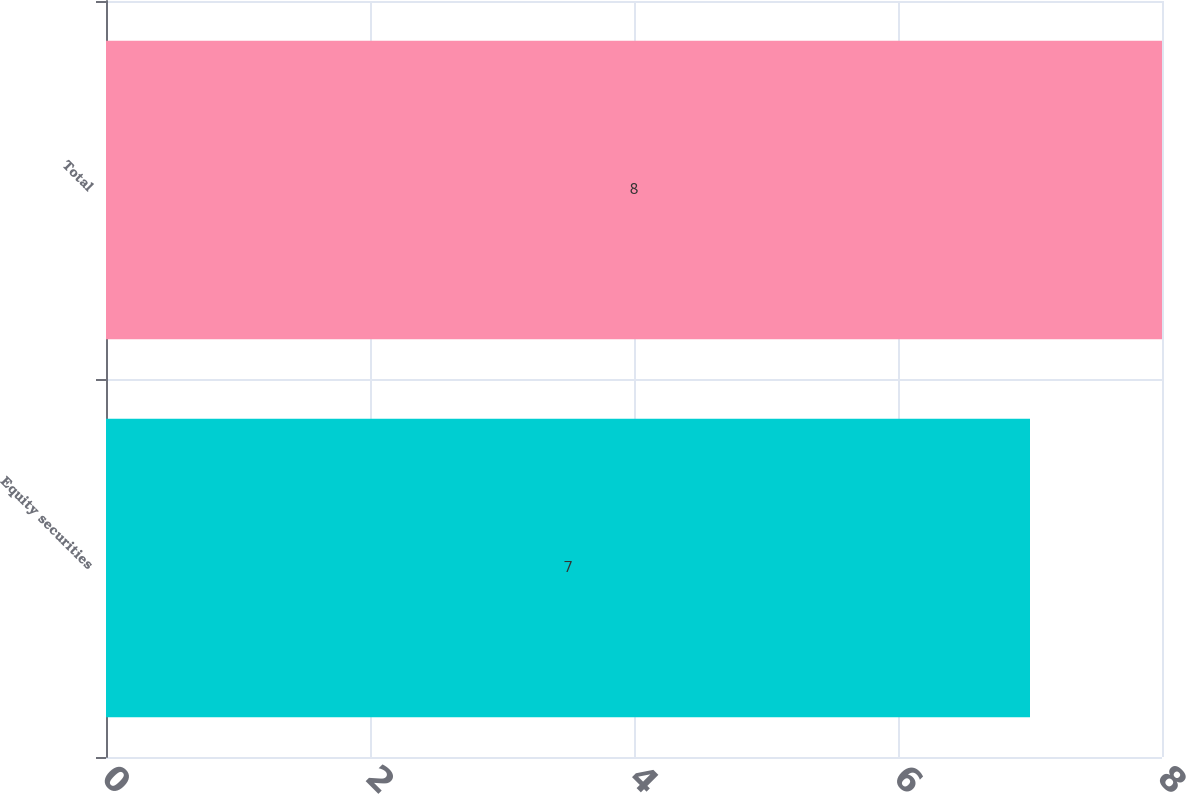<chart> <loc_0><loc_0><loc_500><loc_500><bar_chart><fcel>Equity securities<fcel>Total<nl><fcel>7<fcel>8<nl></chart> 